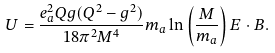<formula> <loc_0><loc_0><loc_500><loc_500>U = \frac { e _ { a } ^ { 2 } Q g ( Q ^ { 2 } - g ^ { 2 } ) } { 1 8 \pi ^ { 2 } M ^ { 4 } } m _ { a } \ln \left ( \frac { M } { m _ { a } } \right ) { E } \cdot { B } .</formula> 